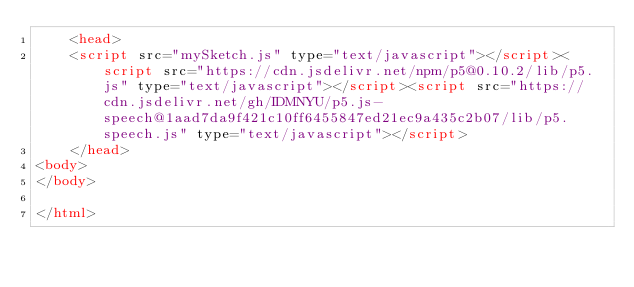Convert code to text. <code><loc_0><loc_0><loc_500><loc_500><_HTML_>    <head>
    <script src="mySketch.js" type="text/javascript"></script><script src="https://cdn.jsdelivr.net/npm/p5@0.10.2/lib/p5.js" type="text/javascript"></script><script src="https://cdn.jsdelivr.net/gh/IDMNYU/p5.js-speech@1aad7da9f421c10ff6455847ed21ec9a435c2b07/lib/p5.speech.js" type="text/javascript"></script>
    </head>
<body>
</body>

</html></code> 